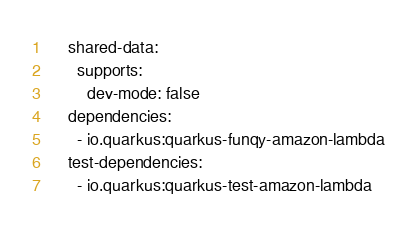Convert code to text. <code><loc_0><loc_0><loc_500><loc_500><_YAML_>    shared-data:
      supports:
        dev-mode: false
    dependencies:
      - io.quarkus:quarkus-funqy-amazon-lambda
    test-dependencies:
      - io.quarkus:quarkus-test-amazon-lambda
</code> 